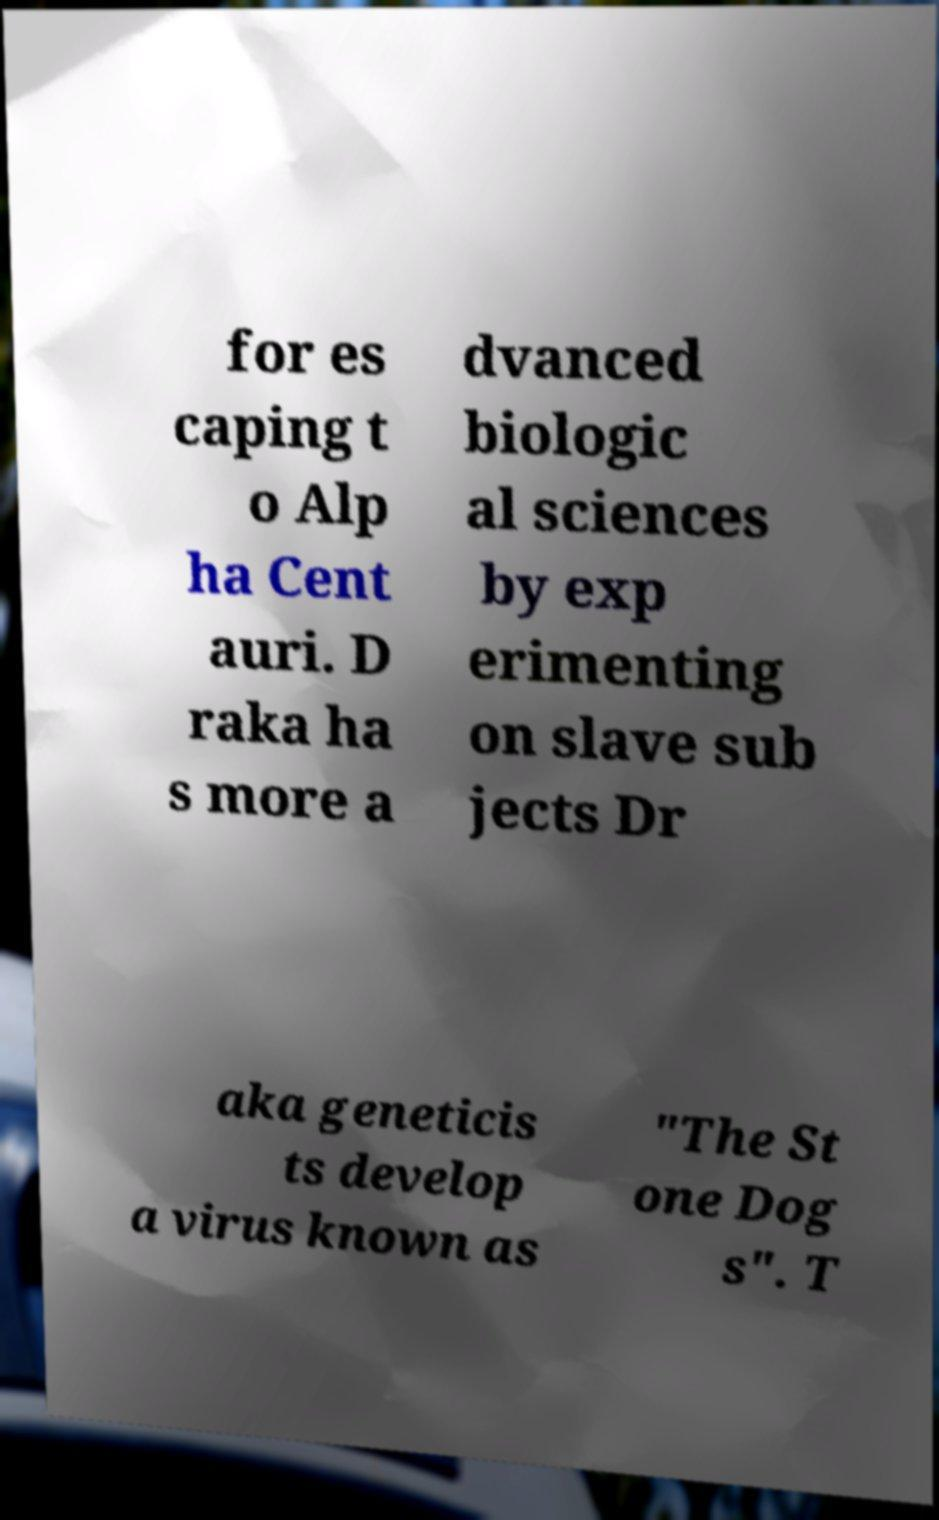Can you accurately transcribe the text from the provided image for me? for es caping t o Alp ha Cent auri. D raka ha s more a dvanced biologic al sciences by exp erimenting on slave sub jects Dr aka geneticis ts develop a virus known as "The St one Dog s". T 